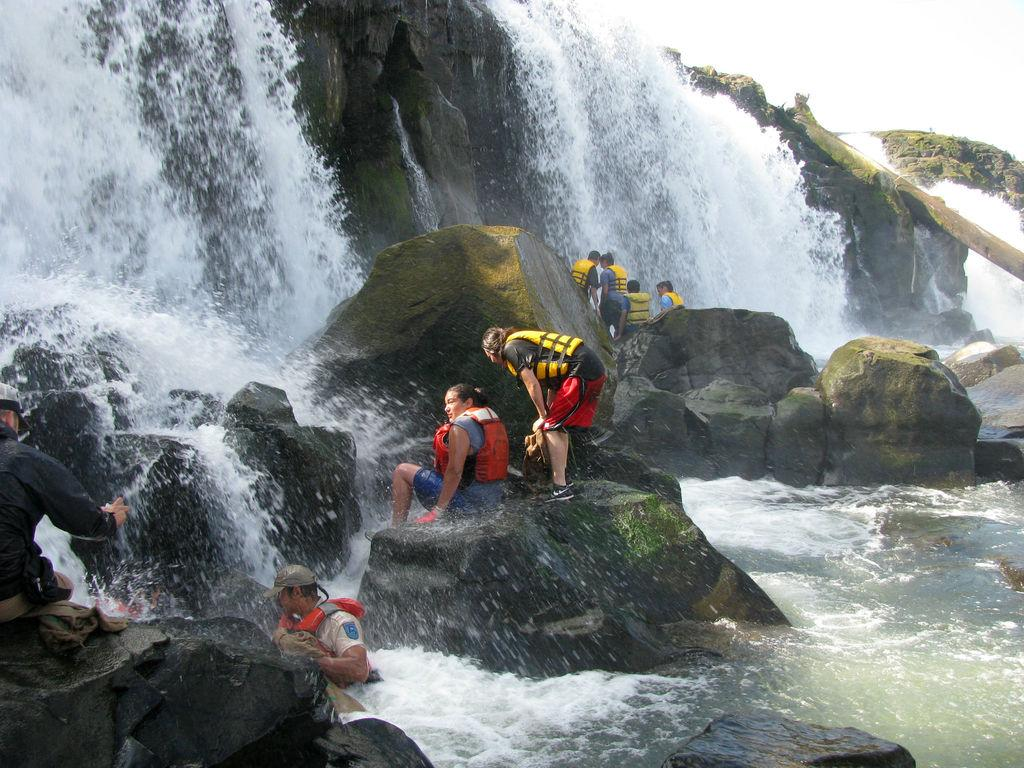What natural feature is the main subject of the image? There is a waterfall in the image. What is happening to the water in the waterfall? Water is flowing in the waterfall. What type of geological formation can be seen in the image? There are rocks in the image. What are the people in the image doing? There are people standing and sitting in the image. Is anyone interacting with the water in the image? Yes, there is a person standing in the water. What type of shock can be seen affecting the ducks in the image? There are no ducks present in the image, so no shock can be observed. How many rings are visible on the person standing in the water? There is no mention of rings in the image, so it cannot be determined if any are visible. 